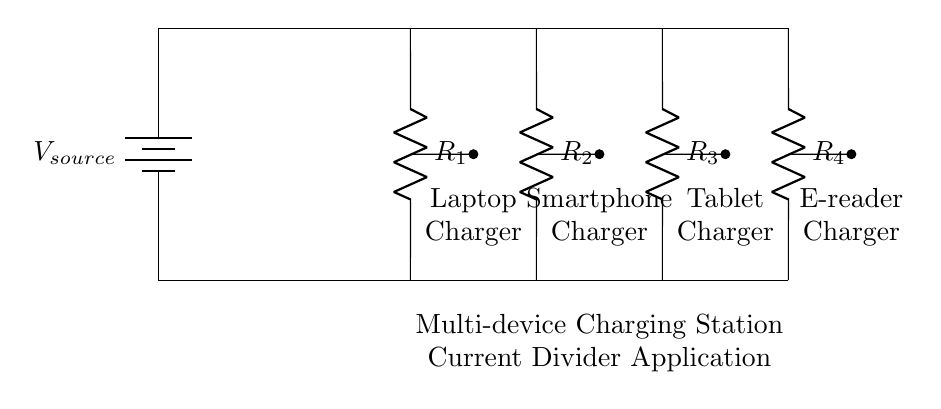What is the purpose of the resistors in this circuit? The resistors serve to divide the current flowing from the battery among the connected chargers. Each resistor's value determines how much current flows through each corresponding charger, allowing multiple devices to be powered simultaneously.
Answer: To divide current Which devices are connected to this charging station? The circuit diagram shows a laptop charger, smartphone charger, tablet charger, and e-reader charger. These devices are represented in the schematic and connected to the respective resistors.
Answer: Laptop, smartphone, tablet, e-reader What type of circuit is illustrated here? This is a current divider circuit because it splits the incoming current from the source into portions that flow through the various parallel devices (chargers). Each device receives a share of the current based on the resistance values.
Answer: Current divider What happens to the total current when one of the resistors is removed? Removing one of the resistors decreases the total resistance of the circuit. This would increase the total current flowing from the battery according to Ohm's law, as the current is inversely proportional to resistance in a parallel circuit configuration.
Answer: Increases total current If one charger is drawing less current than another, what could that indicate about the corresponding resistor? If one charger is drawing less current, it could indicate that the corresponding resistor has a larger resistance value compared to the others. In a current divider, higher resistance results in lower current flow according to the formula for current division.
Answer: Higher resistance How does the voltage across each charger compare in this setup? The voltage across each charger remains the same because they are all connected in parallel. The voltage across parallel components in a circuit is equal to the source voltage.
Answer: Equal to source voltage 